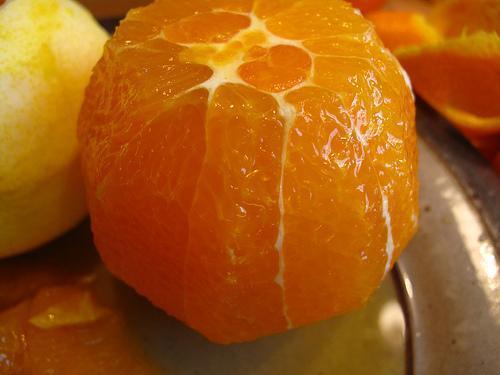How many peeled oranges are there?
Give a very brief answer. 1. 